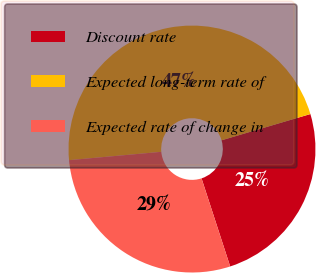Convert chart. <chart><loc_0><loc_0><loc_500><loc_500><pie_chart><fcel>Discount rate<fcel>Expected long-term rate of<fcel>Expected rate of change in<nl><fcel>24.57%<fcel>46.86%<fcel>28.57%<nl></chart> 